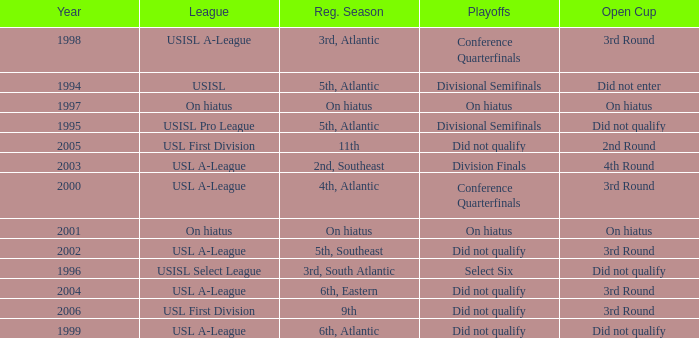Could you parse the entire table as a dict? {'header': ['Year', 'League', 'Reg. Season', 'Playoffs', 'Open Cup'], 'rows': [['1998', 'USISL A-League', '3rd, Atlantic', 'Conference Quarterfinals', '3rd Round'], ['1994', 'USISL', '5th, Atlantic', 'Divisional Semifinals', 'Did not enter'], ['1997', 'On hiatus', 'On hiatus', 'On hiatus', 'On hiatus'], ['1995', 'USISL Pro League', '5th, Atlantic', 'Divisional Semifinals', 'Did not qualify'], ['2005', 'USL First Division', '11th', 'Did not qualify', '2nd Round'], ['2003', 'USL A-League', '2nd, Southeast', 'Division Finals', '4th Round'], ['2000', 'USL A-League', '4th, Atlantic', 'Conference Quarterfinals', '3rd Round'], ['2001', 'On hiatus', 'On hiatus', 'On hiatus', 'On hiatus'], ['2002', 'USL A-League', '5th, Southeast', 'Did not qualify', '3rd Round'], ['1996', 'USISL Select League', '3rd, South Atlantic', 'Select Six', 'Did not qualify'], ['2004', 'USL A-League', '6th, Eastern', 'Did not qualify', '3rd Round'], ['2006', 'USL First Division', '9th', 'Did not qualify', '3rd Round'], ['1999', 'USL A-League', '6th, Atlantic', 'Did not qualify', 'Did not qualify']]} What was the earliest year for the USISL Pro League? 1995.0. 